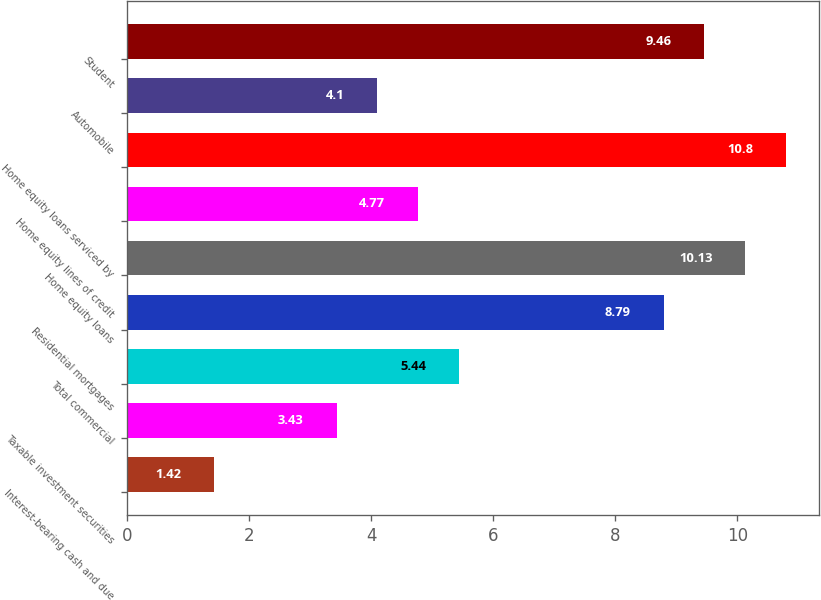Convert chart to OTSL. <chart><loc_0><loc_0><loc_500><loc_500><bar_chart><fcel>Interest-bearing cash and due<fcel>Taxable investment securities<fcel>Total commercial<fcel>Residential mortgages<fcel>Home equity loans<fcel>Home equity lines of credit<fcel>Home equity loans serviced by<fcel>Automobile<fcel>Student<nl><fcel>1.42<fcel>3.43<fcel>5.44<fcel>8.79<fcel>10.13<fcel>4.77<fcel>10.8<fcel>4.1<fcel>9.46<nl></chart> 